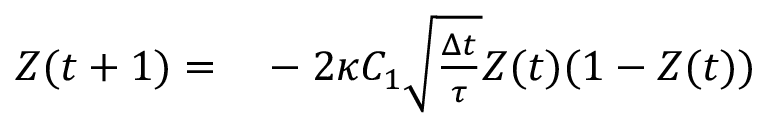<formula> <loc_0><loc_0><loc_500><loc_500>\begin{array} { r l } { Z ( t + 1 ) = } & - 2 \kappa C _ { 1 } \sqrt { \frac { \Delta t } { \tau } } Z ( t ) ( 1 - Z ( t ) ) } \end{array}</formula> 